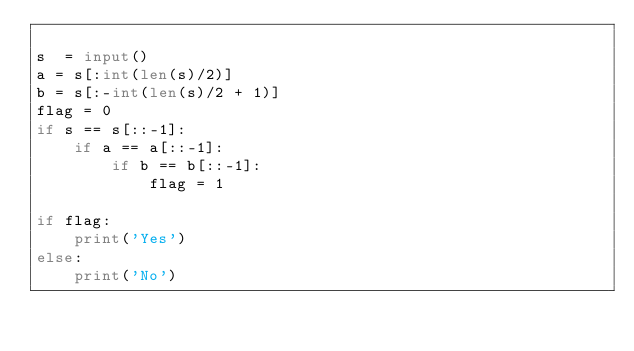<code> <loc_0><loc_0><loc_500><loc_500><_Python_>
s  = input()
a = s[:int(len(s)/2)]
b = s[:-int(len(s)/2 + 1)]
flag = 0
if s == s[::-1]:
    if a == a[::-1]:
        if b == b[::-1]:
            flag = 1

if flag:
    print('Yes')
else:
    print('No')</code> 